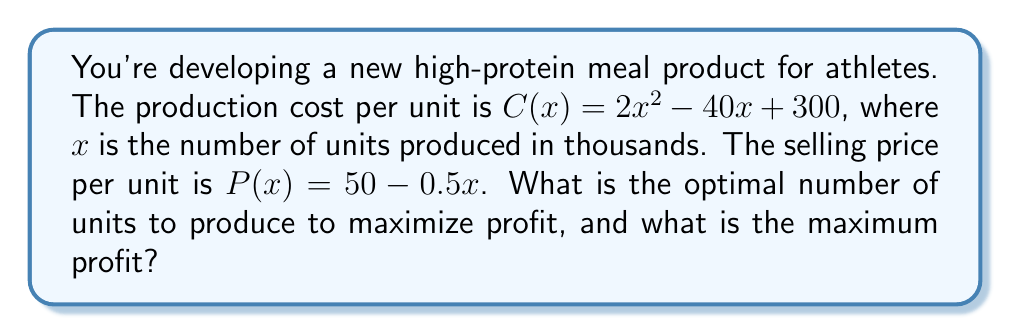Show me your answer to this math problem. To solve this problem, we need to follow these steps:

1) First, let's define the profit function. Profit is revenue minus cost:
   $\text{Profit} = \text{Revenue} - \text{Cost}$
   $\pi(x) = xP(x) - C(x)$

2) Substitute the given functions:
   $\pi(x) = x(50 - 0.5x) - (2x^2 - 40x + 300)$

3) Expand the equation:
   $\pi(x) = 50x - 0.5x^2 - 2x^2 + 40x - 300$
   $\pi(x) = -2.5x^2 + 90x - 300$

4) To find the maximum profit, we need to find where the derivative of the profit function equals zero:
   $\frac{d\pi}{dx} = -5x + 90 = 0$

5) Solve for x:
   $-5x = -90$
   $x = 18$

6) To confirm this is a maximum, check the second derivative:
   $\frac{d^2\pi}{dx^2} = -5$, which is negative, confirming a maximum.

7) The optimal number of units to produce is 18,000 (remember x was in thousands).

8) To find the maximum profit, substitute x = 18 into the profit function:
   $\pi(18) = -2.5(18)^2 + 90(18) - 300$
   $\pi(18) = -810 + 1620 - 300 = 510$

Therefore, the maximum profit is $510,000.
Answer: The optimal number of units to produce is 18,000, and the maximum profit is $510,000. 